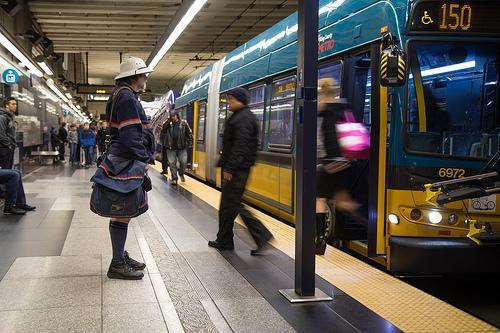How many trains are there?
Give a very brief answer. 1. 